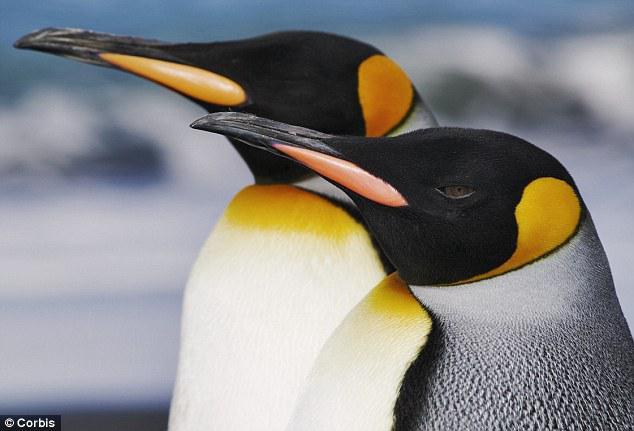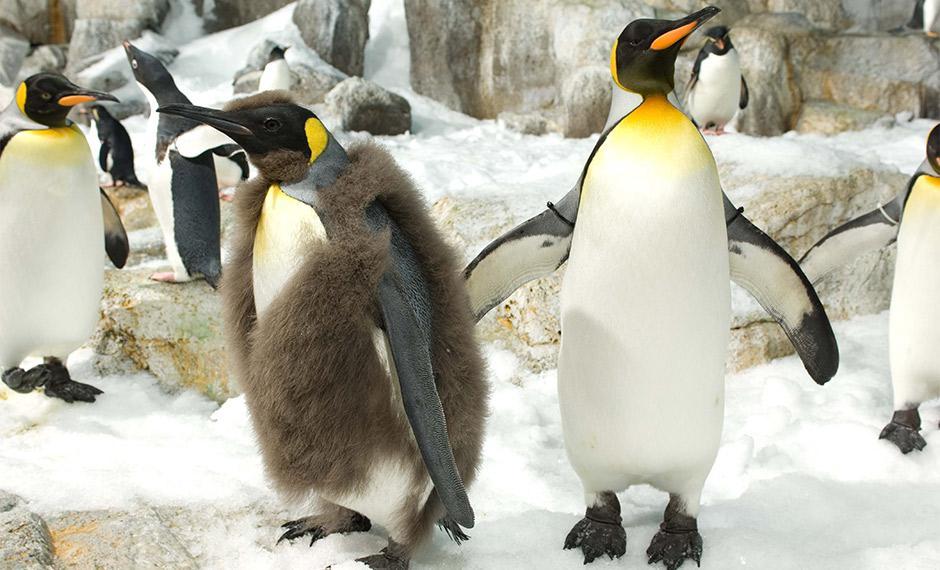The first image is the image on the left, the second image is the image on the right. Considering the images on both sides, is "There are exactly three animals in the image on the right." valid? Answer yes or no. No. The first image is the image on the left, the second image is the image on the right. Assess this claim about the two images: "A penguin in the foreground is at least partly covered in brown fuzzy feathers.". Correct or not? Answer yes or no. Yes. 